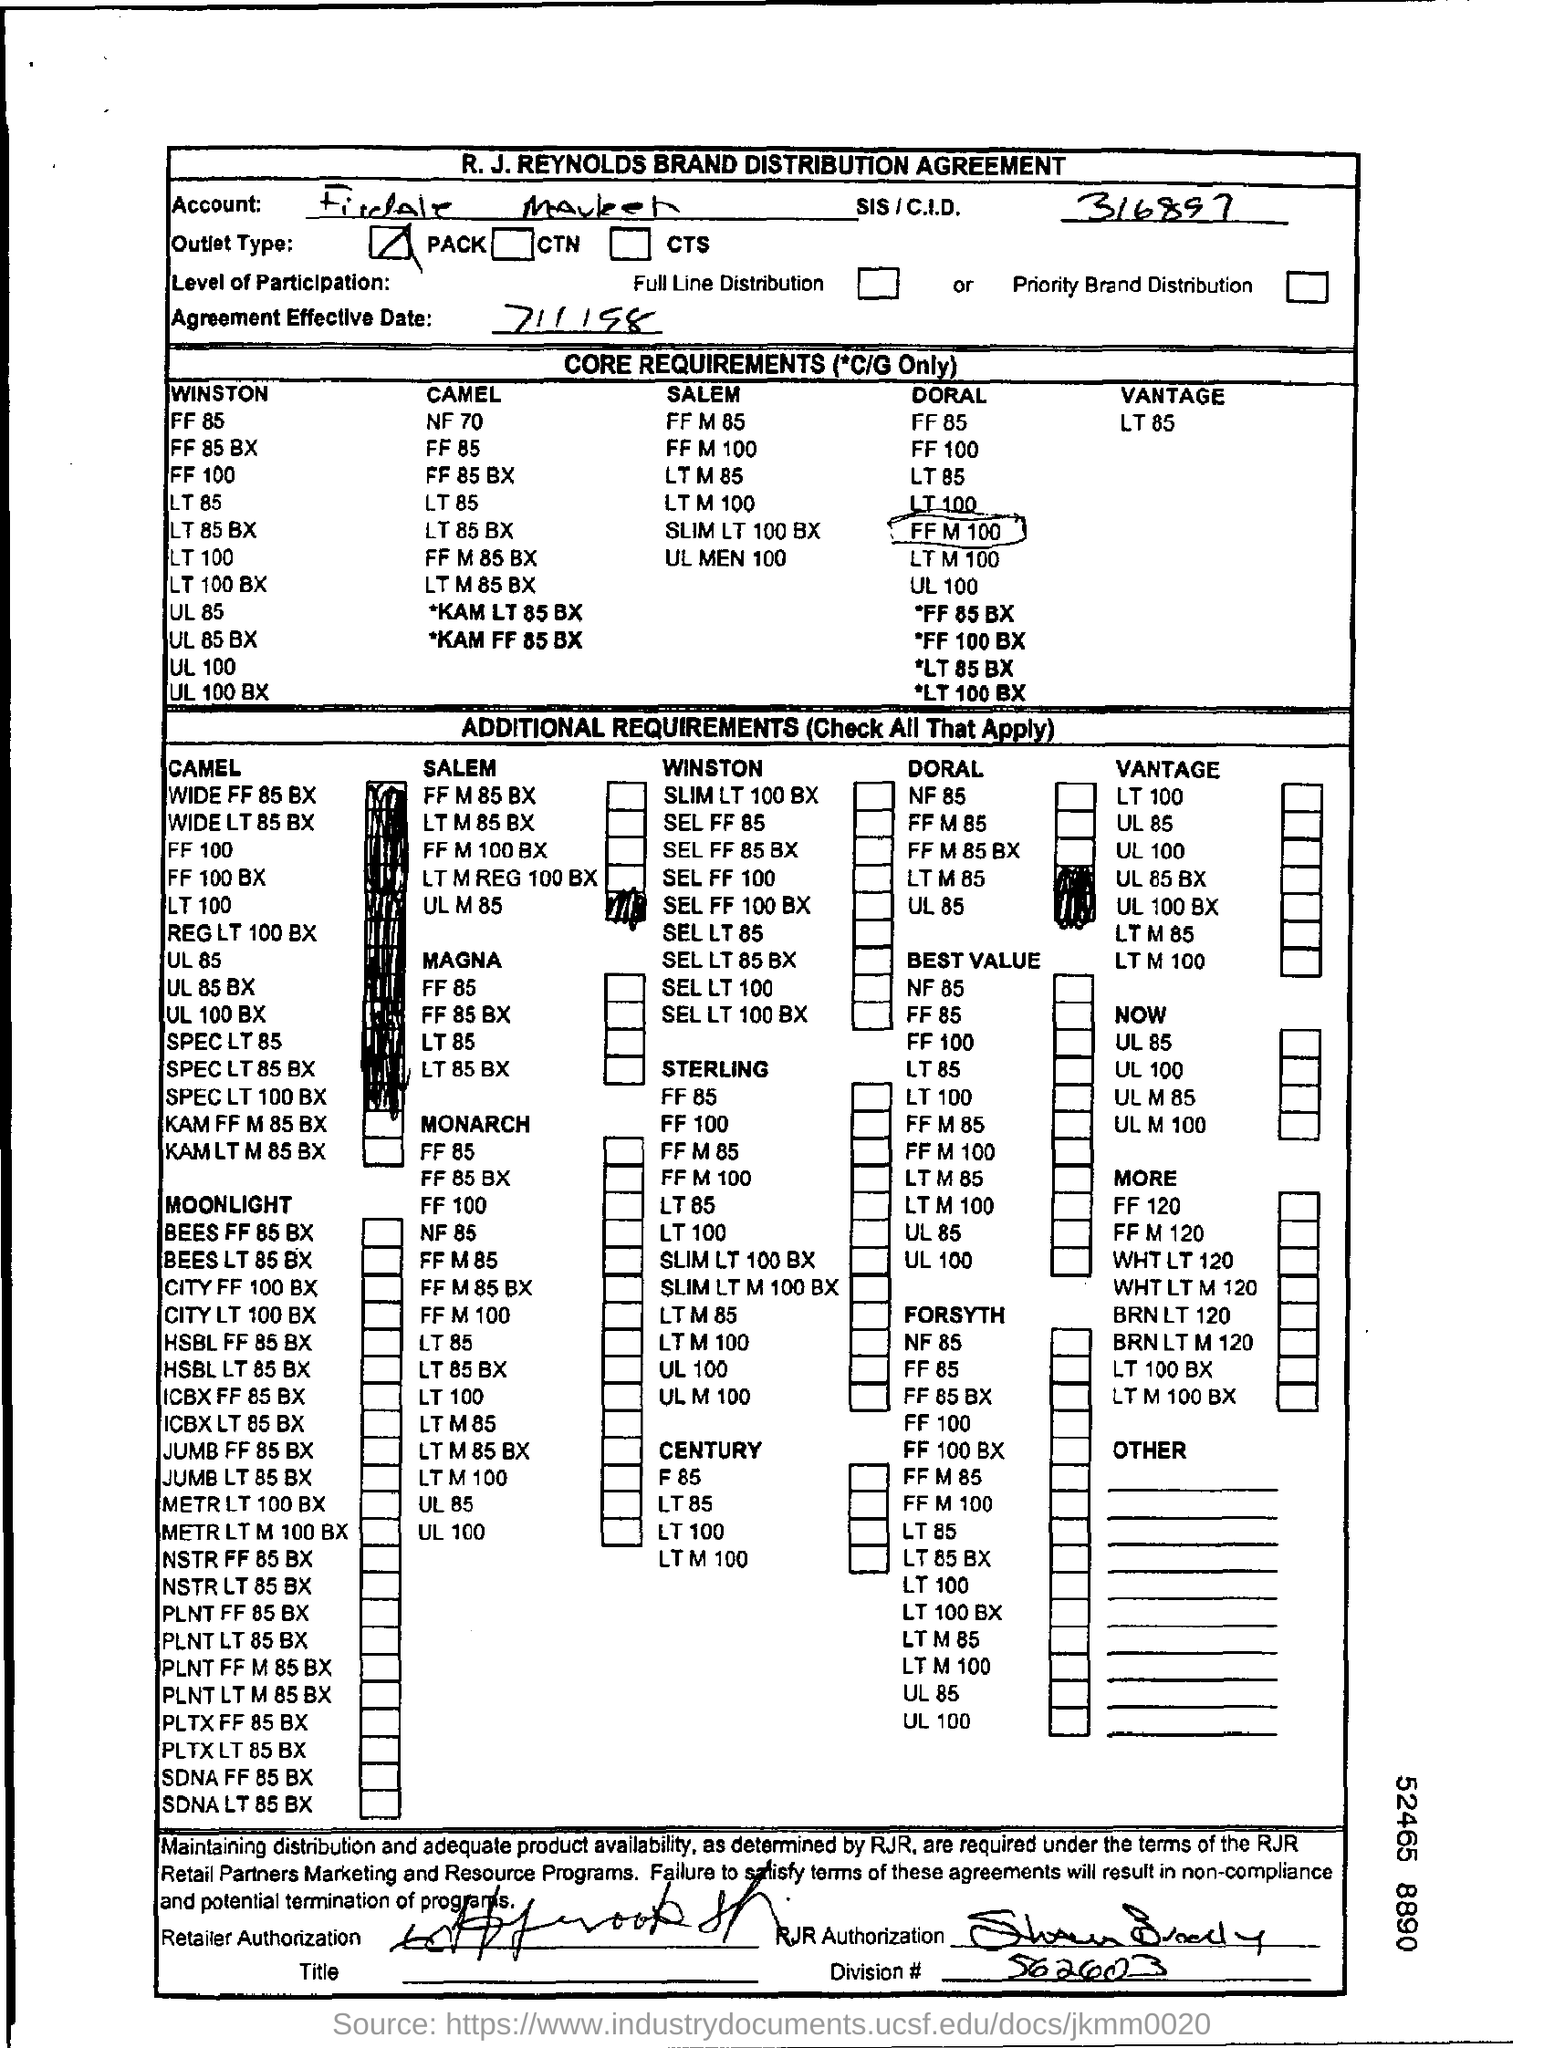What is the division# mentioned in the form?
Offer a very short reply. 562603. What is the SIS/C.I.D.?
Give a very brief answer. 316897. What is the outlet type?
Give a very brief answer. PACK. What is the agreement effective date?
Your answer should be very brief. 7/1/98. What is the division #?
Offer a terse response. 562603. 